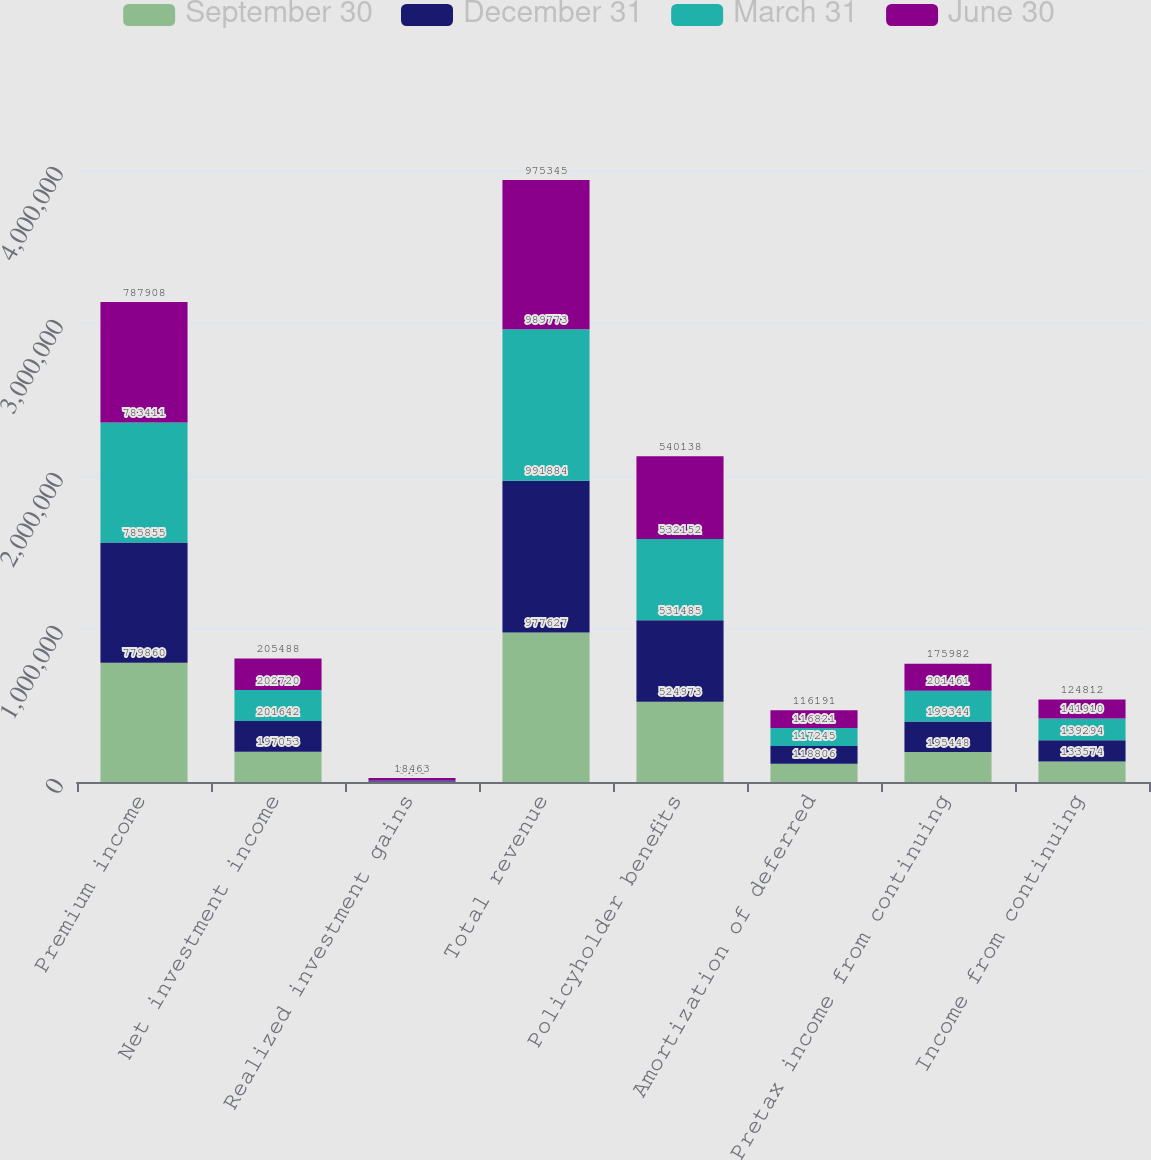Convert chart to OTSL. <chart><loc_0><loc_0><loc_500><loc_500><stacked_bar_chart><ecel><fcel>Premium income<fcel>Net investment income<fcel>Realized investment gains<fcel>Total revenue<fcel>Policyholder benefits<fcel>Amortization of deferred<fcel>Pretax income from continuing<fcel>Income from continuing<nl><fcel>September 30<fcel>779860<fcel>197053<fcel>293<fcel>977627<fcel>524973<fcel>118806<fcel>195448<fcel>133574<nl><fcel>December 31<fcel>785855<fcel>201642<fcel>4005<fcel>991884<fcel>531485<fcel>117245<fcel>199344<fcel>139294<nl><fcel>March 31<fcel>783411<fcel>202720<fcel>3482<fcel>989773<fcel>532152<fcel>116821<fcel>201461<fcel>141910<nl><fcel>June 30<fcel>787908<fcel>205488<fcel>18463<fcel>975345<fcel>540138<fcel>116191<fcel>175982<fcel>124812<nl></chart> 